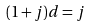<formula> <loc_0><loc_0><loc_500><loc_500>( 1 + j ) d = j</formula> 